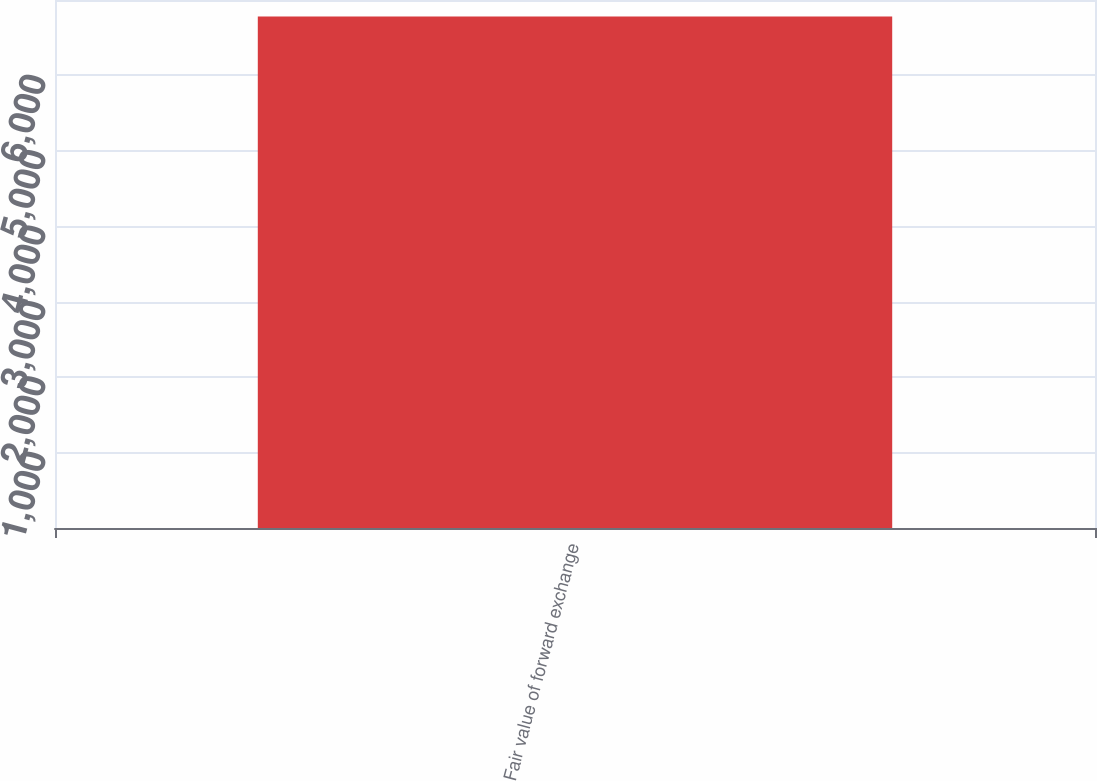<chart> <loc_0><loc_0><loc_500><loc_500><bar_chart><fcel>Fair value of forward exchange<nl><fcel>6781<nl></chart> 